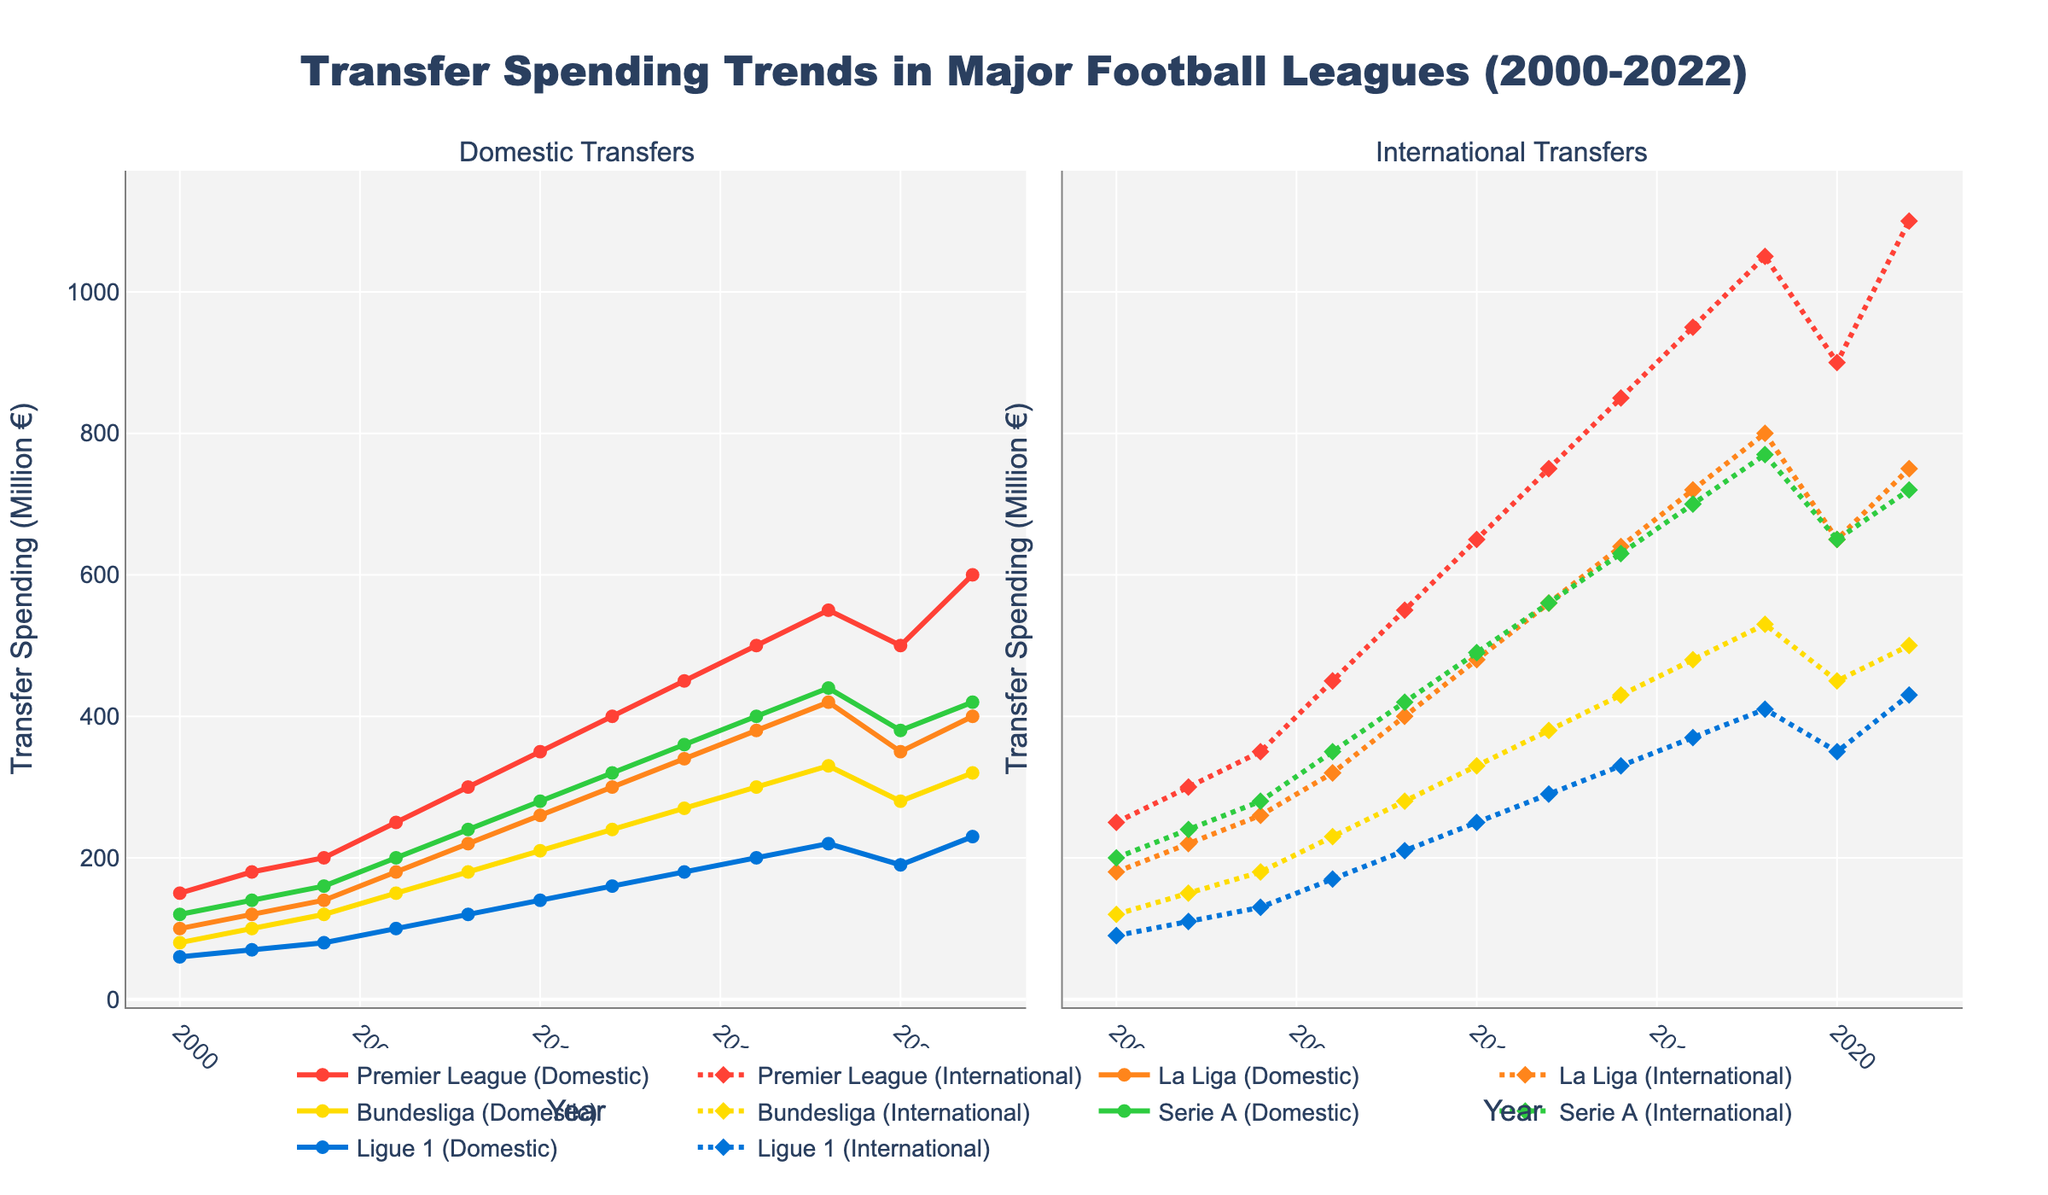Which league had the highest spending on international transfers in 2022? Look at the 'International Transfers' column for 2022 and identify the league with the highest value. The Premier League shows 1100 million €, which is the highest.
Answer: Premier League How did the spending on domestic transfers in the Premier League change from 2000 to 2022? Find the values for the Premier League (Domestic) for 2000 and 2022 and calculate the difference: 150 million € (2000) to 600 million € (2022). The spending increased by 450 million €.
Answer: Increased by 450 million € Which two leagues had the closest spending on international transfers in 2016? Compare the international transfer values for all leagues in 2016. La Liga and Serie A both had values around 720 million € and 700 million €, respectively, making them the closest.
Answer: La Liga and Serie A What's the total spending on domestic transfers across all leagues in 2020? Sum the values of domestic transfers for all leagues in 2020: 500 (Premier League) + 350 (La Liga) + 280 (Bundesliga) + 380 (Serie A) + 190 (Ligue 1) = 1700 million €.
Answer: 1700 million € How did transfer spending trends change in Ligue 1 for international transfers from 2010 to 2022? Check Ligue 1 (International) values in 2010 and 2022: 250 million € in 2010 and 430 million € in 2022. The spending increased by 180 million €.
Answer: Increased by 180 million € Between 2008 and 2014, which league saw the highest increase in international transfer spending? Find the values for 2008 and 2014 for each league under the international transfers and calculate the changes: 
  - Premier League: 850 - 550 = 300 million €
  - La Liga: 640 - 400 = 240 million €
  - Bundesliga: 430 - 280 = 150 million €
  - Serie A: 630 - 420 = 210 million €
  - Ligue 1: 330 - 210 = 120 million €
The Premier League saw the highest increase.
Answer: Premier League What's the average spending on domestic transfers for La Liga from 2000 to 2022? Add the values for La Liga (Domestic) from 2000 to 2022 and then divide by the number of years: 
  (100 + 120 + 140 + 180 + 220 + 260 + 300 + 340 + 380 + 420 + 350 + 400) / 12
  = 321.67 million €.
Answer: 321.67 million € How did the international transfer spending trend in the Bundesliga compare to Serie A from 2008 to 2018? Inspect the values for international transfers in 2008 and 2018 for Bundesliga and Serie A:
  - Bundesliga: from 280 million € (2008) to 530 million € (2018), an increase of 250 million €.
  - Serie A: from 420 million € (2008) to 770 million € (2018), an increase of 350 million €.
Serie A had a higher increase in international transfer spending compared to Bundesliga.
Answer: Serie A had a higher increase Visually, which league had the most steady increase in domestic transfer spending over the years? Observe the slopes of the lines in the domestic transfer plot. The Premier League's line ascends steadily without dramatic changes, indicating the most consistent increase.
Answer: Premier League What was the difference in domestic transfer spending between Ligue 1 and the Bundesliga in 2014? Find the values for domestic transfers in 2014: Ligue 1 (180 million €) and Bundesliga (270 million €). The difference is 270 - 180 = 90 million €.
Answer: 90 million € 